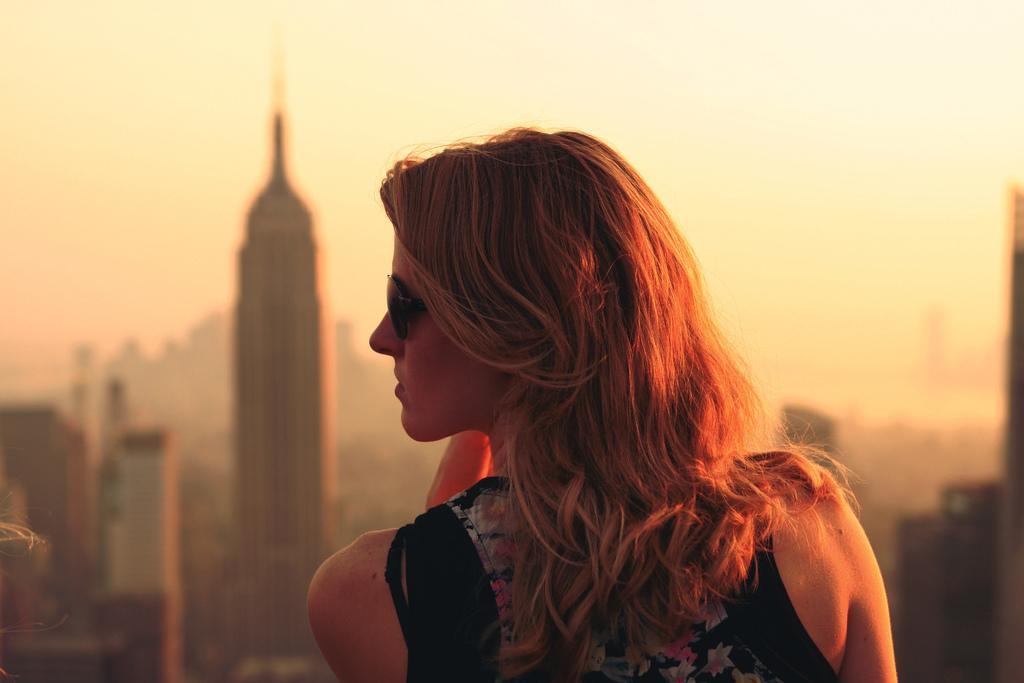Could you give a brief overview of what you see in this image? In this picture we can see a woman and few buildings in the background. 